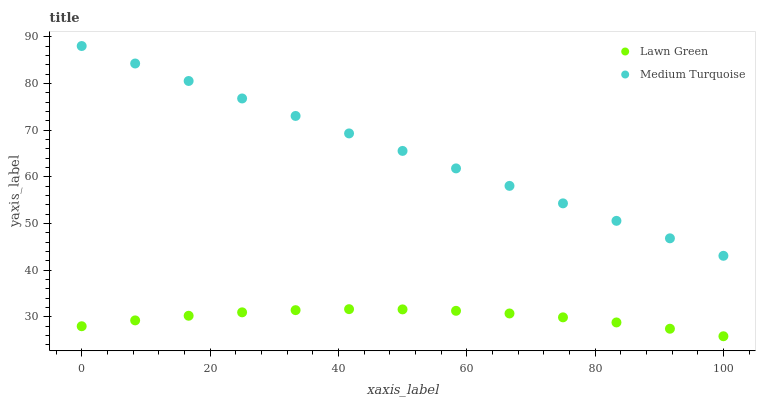Does Lawn Green have the minimum area under the curve?
Answer yes or no. Yes. Does Medium Turquoise have the maximum area under the curve?
Answer yes or no. Yes. Does Medium Turquoise have the minimum area under the curve?
Answer yes or no. No. Is Medium Turquoise the smoothest?
Answer yes or no. Yes. Is Lawn Green the roughest?
Answer yes or no. Yes. Is Medium Turquoise the roughest?
Answer yes or no. No. Does Lawn Green have the lowest value?
Answer yes or no. Yes. Does Medium Turquoise have the lowest value?
Answer yes or no. No. Does Medium Turquoise have the highest value?
Answer yes or no. Yes. Is Lawn Green less than Medium Turquoise?
Answer yes or no. Yes. Is Medium Turquoise greater than Lawn Green?
Answer yes or no. Yes. Does Lawn Green intersect Medium Turquoise?
Answer yes or no. No. 